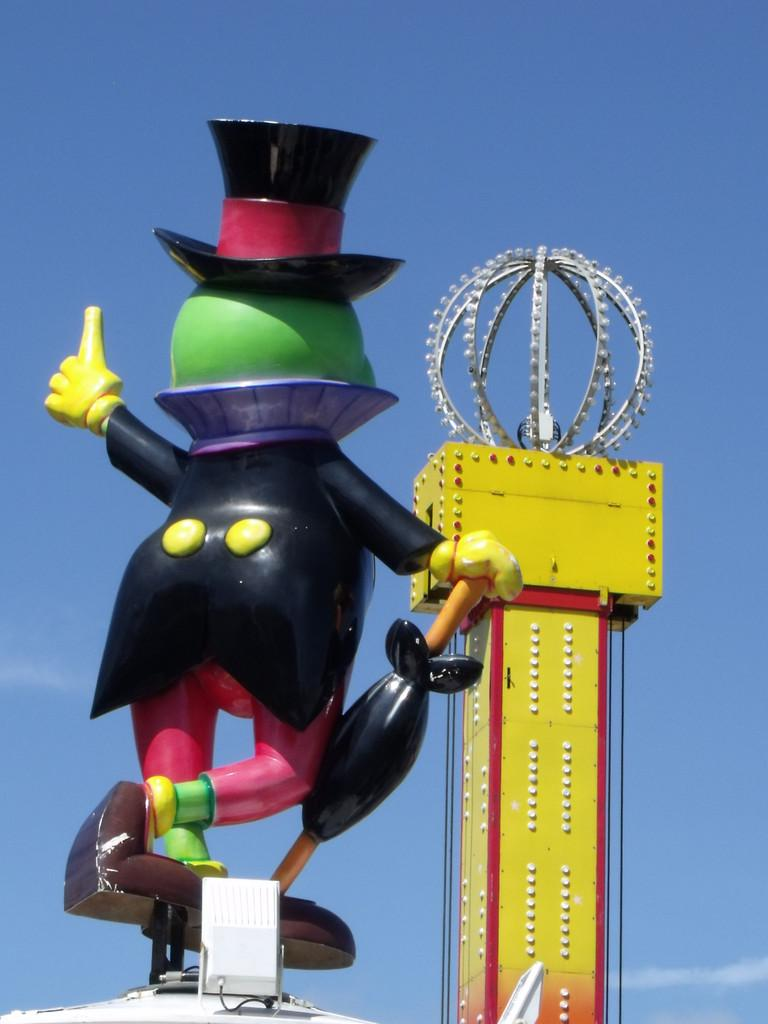What type of object is in the image? There is a multi-colored toy in the image. What can be seen in the background of the image? There is a tower in the background of the image. What colors are present on the tower? The tower has yellow and red colors. What is the color of the sky in the image? The sky is blue and white in color. How many ministers are present in the image? There are no ministers present in the image. What type of crowd can be seen gathering around the toy in the image? There is no crowd present in the image; it only features a multi-colored toy and a tower in the background. 